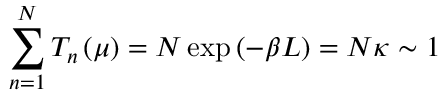<formula> <loc_0><loc_0><loc_500><loc_500>\sum _ { n = 1 } ^ { N } T _ { n } \left ( \mu \right ) = N \exp \left ( - \beta L \right ) = N \kappa \sim 1</formula> 